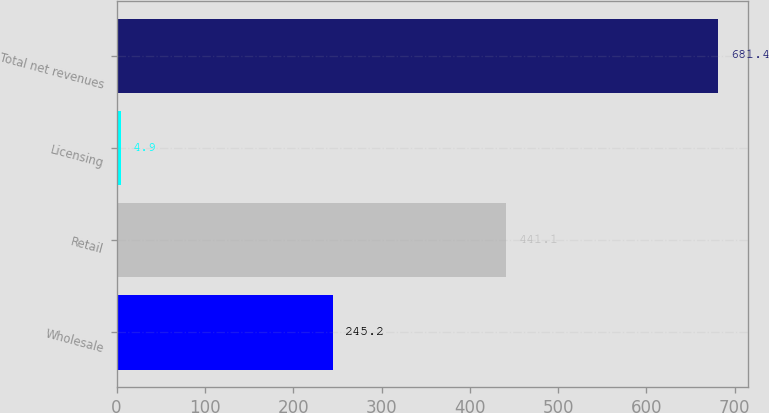Convert chart. <chart><loc_0><loc_0><loc_500><loc_500><bar_chart><fcel>Wholesale<fcel>Retail<fcel>Licensing<fcel>Total net revenues<nl><fcel>245.2<fcel>441.1<fcel>4.9<fcel>681.4<nl></chart> 